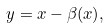Convert formula to latex. <formula><loc_0><loc_0><loc_500><loc_500>y = x - \beta ( x ) ,</formula> 